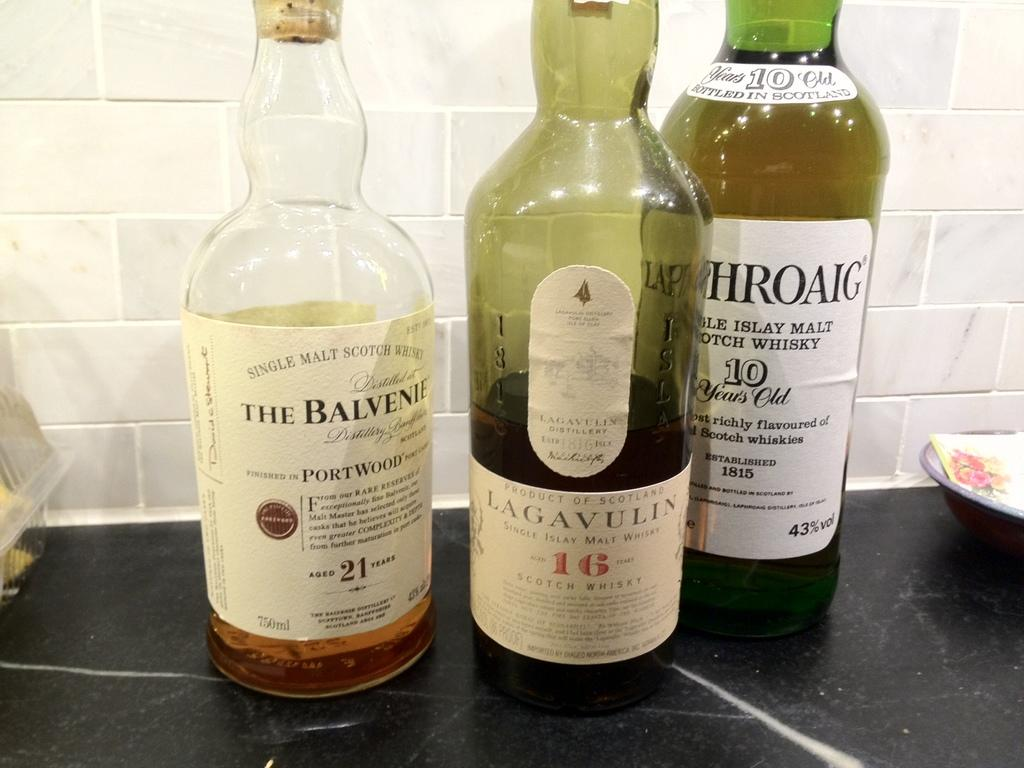<image>
Relay a brief, clear account of the picture shown. Bottles of whiskey including The Balvenie and Lagavulin. 